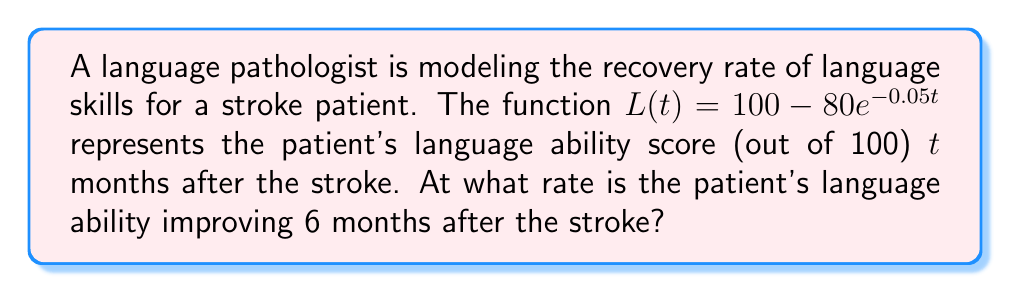Can you answer this question? To find the rate at which the patient's language ability is improving 6 months after the stroke, we need to find the derivative of $L(t)$ and evaluate it at $t=6$. Here's the step-by-step process:

1) First, let's find the derivative of $L(t)$:
   $L(t) = 100 - 80e^{-0.05t}$
   $L'(t) = -80 \cdot (-0.05e^{-0.05t})$ (using the chain rule)
   $L'(t) = 4e^{-0.05t}$

2) Now, we need to evaluate $L'(6)$:
   $L'(6) = 4e^{-0.05(6)}$
   $L'(6) = 4e^{-0.3}$

3) Calculate the value:
   $L'(6) = 4 \cdot 0.7408 \approx 2.9632$

The rate of improvement is approximately 2.9632 points per month at 6 months post-stroke.
Answer: $2.9632$ points per month 